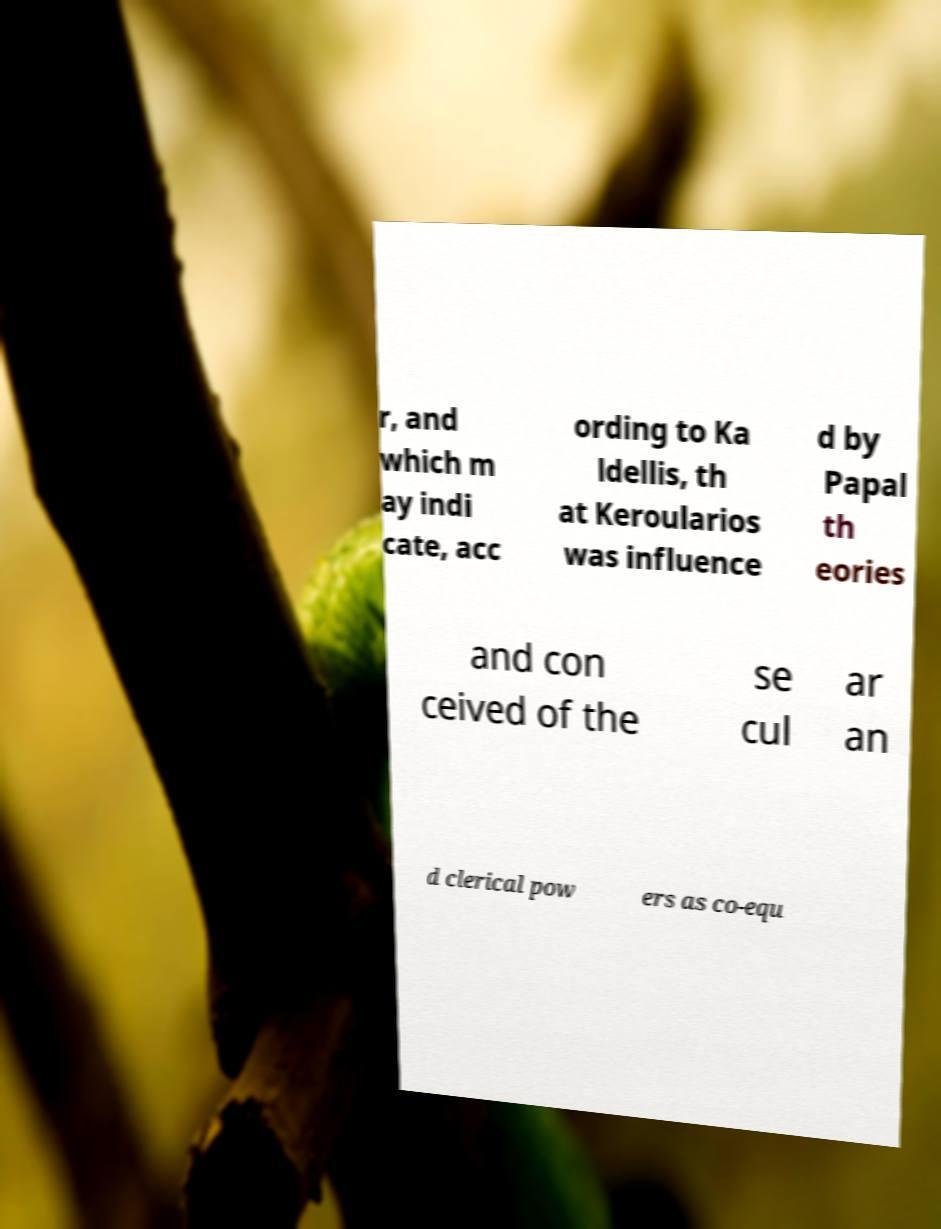Please identify and transcribe the text found in this image. r, and which m ay indi cate, acc ording to Ka ldellis, th at Keroularios was influence d by Papal th eories and con ceived of the se cul ar an d clerical pow ers as co-equ 